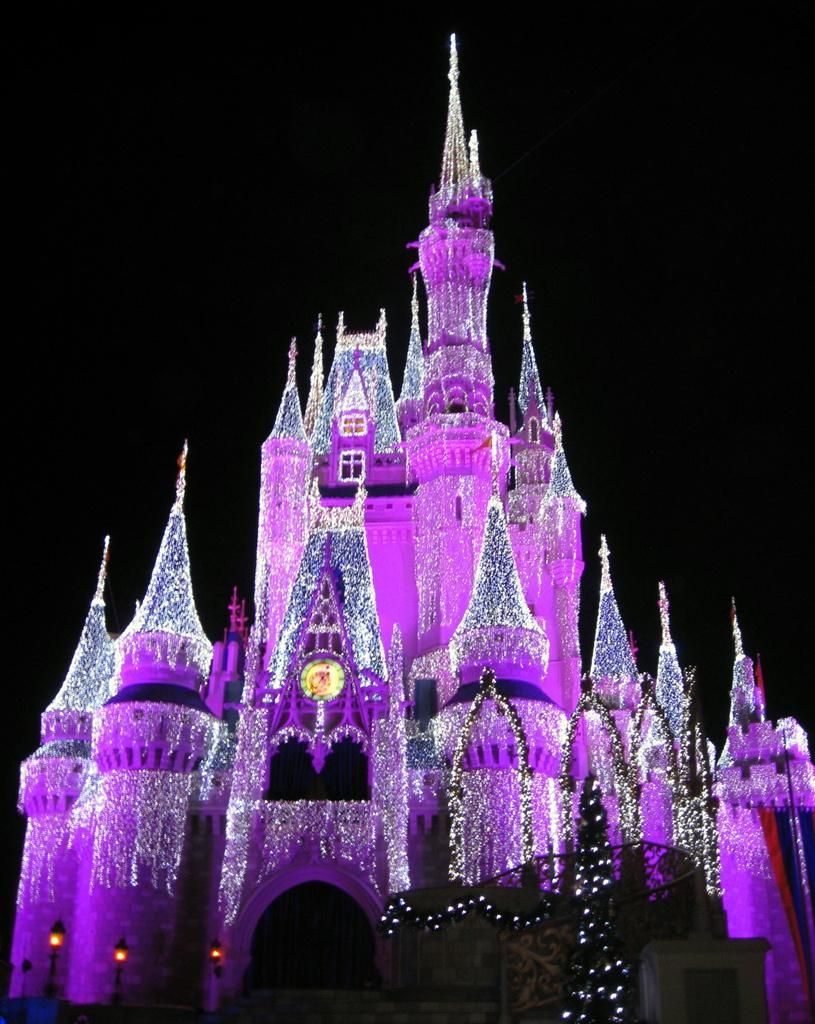What is the main subject in the middle of the image? There is a building in the middle of the image. Can you describe any specific features of the building? There is a window with lights in the image. What is the color of the background in the image? The background of the image is black. How many pigs are visible in the image? There are no pigs present in the image. What type of store can be seen in the background of the image? There is no store visible in the image, as the background is black. 